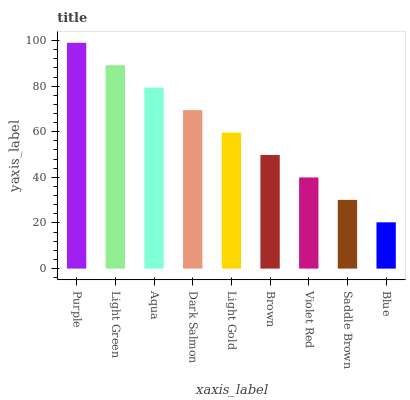Is Light Green the minimum?
Answer yes or no. No. Is Light Green the maximum?
Answer yes or no. No. Is Purple greater than Light Green?
Answer yes or no. Yes. Is Light Green less than Purple?
Answer yes or no. Yes. Is Light Green greater than Purple?
Answer yes or no. No. Is Purple less than Light Green?
Answer yes or no. No. Is Light Gold the high median?
Answer yes or no. Yes. Is Light Gold the low median?
Answer yes or no. Yes. Is Violet Red the high median?
Answer yes or no. No. Is Brown the low median?
Answer yes or no. No. 